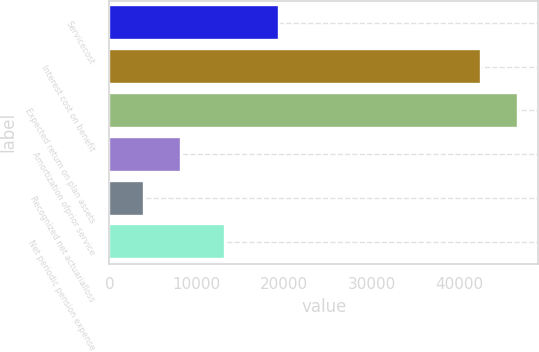Convert chart. <chart><loc_0><loc_0><loc_500><loc_500><bar_chart><fcel>Servicecost<fcel>Interest cost on benefit<fcel>Expected return on plan assets<fcel>Amortization ofprior service<fcel>Recognized net actuarialloss<fcel>Net periodic pension expense<nl><fcel>19409<fcel>42544<fcel>46759<fcel>8157<fcel>3942<fcel>13244<nl></chart> 